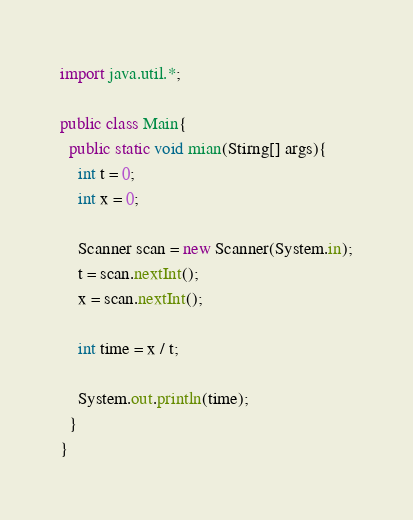Convert code to text. <code><loc_0><loc_0><loc_500><loc_500><_Java_>import java.util.*;

public class Main{
  public static void mian(Stirng[] args){
    int t = 0;
    int x = 0;
    
    Scanner scan = new Scanner(System.in);
    t = scan.nextInt();
    x = scan.nextInt();
    
    int time = x / t;
    
    System.out.println(time);
  }
}</code> 